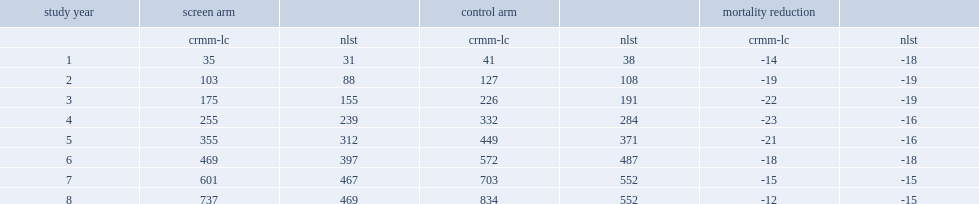What was the percentage of a maximum mortality reduction of the crmm-lc? 23. What was the percentage of a maximum mortality reduction from nlst data? 19. Could you parse the entire table as a dict? {'header': ['study year', 'screen arm', '', 'control arm', '', 'mortality reduction', ''], 'rows': [['', 'crmm-lc', 'nlst', 'crmm-lc', 'nlst', 'crmm-lc', 'nlst'], ['1', '35', '31', '41', '38', '-14', '-18'], ['2', '103', '88', '127', '108', '-19', '-19'], ['3', '175', '155', '226', '191', '-22', '-19'], ['4', '255', '239', '332', '284', '-23', '-16'], ['5', '355', '312', '449', '371', '-21', '-16'], ['6', '469', '397', '572', '487', '-18', '-18'], ['7', '601', '467', '703', '552', '-15', '-15'], ['8', '737', '469', '834', '552', '-12', '-15']]} 